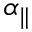<formula> <loc_0><loc_0><loc_500><loc_500>\alpha _ { \| }</formula> 